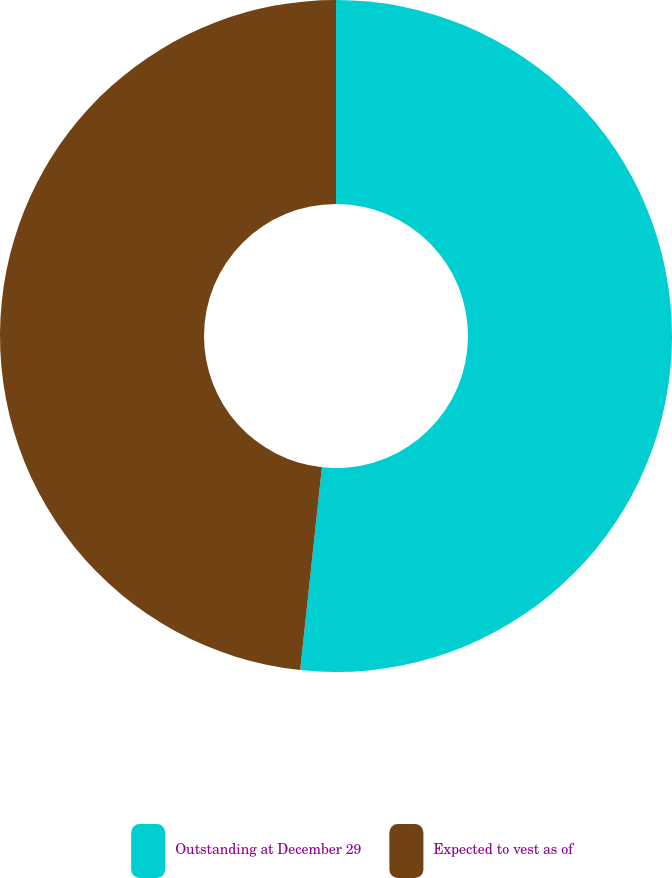Convert chart. <chart><loc_0><loc_0><loc_500><loc_500><pie_chart><fcel>Outstanding at December 29<fcel>Expected to vest as of<nl><fcel>51.7%<fcel>48.3%<nl></chart> 